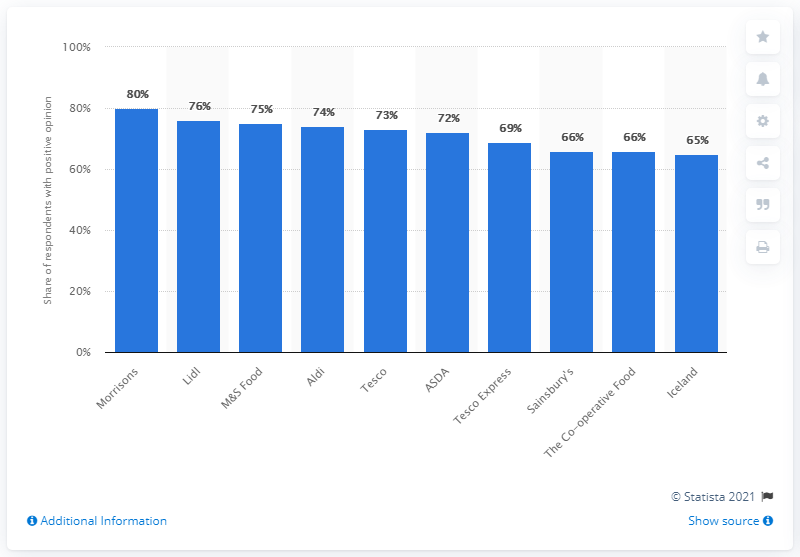List a handful of essential elements in this visual. Tesco was the market leader in the United Kingdom. It is evident that Lidl was the most popular supermarket chain in the United Kingdom. It is widely acknowledged that Morrisons is the most popular supermarket chain in the United Kingdom. 